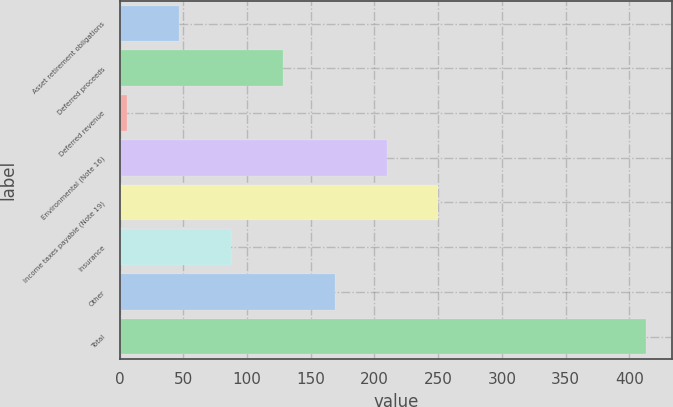Convert chart. <chart><loc_0><loc_0><loc_500><loc_500><bar_chart><fcel>Asset retirement obligations<fcel>Deferred proceeds<fcel>Deferred revenue<fcel>Environmental (Note 16)<fcel>Income taxes payable (Note 19)<fcel>Insurance<fcel>Other<fcel>Total<nl><fcel>46.7<fcel>128.1<fcel>6<fcel>209.5<fcel>250.2<fcel>87.4<fcel>168.8<fcel>413<nl></chart> 